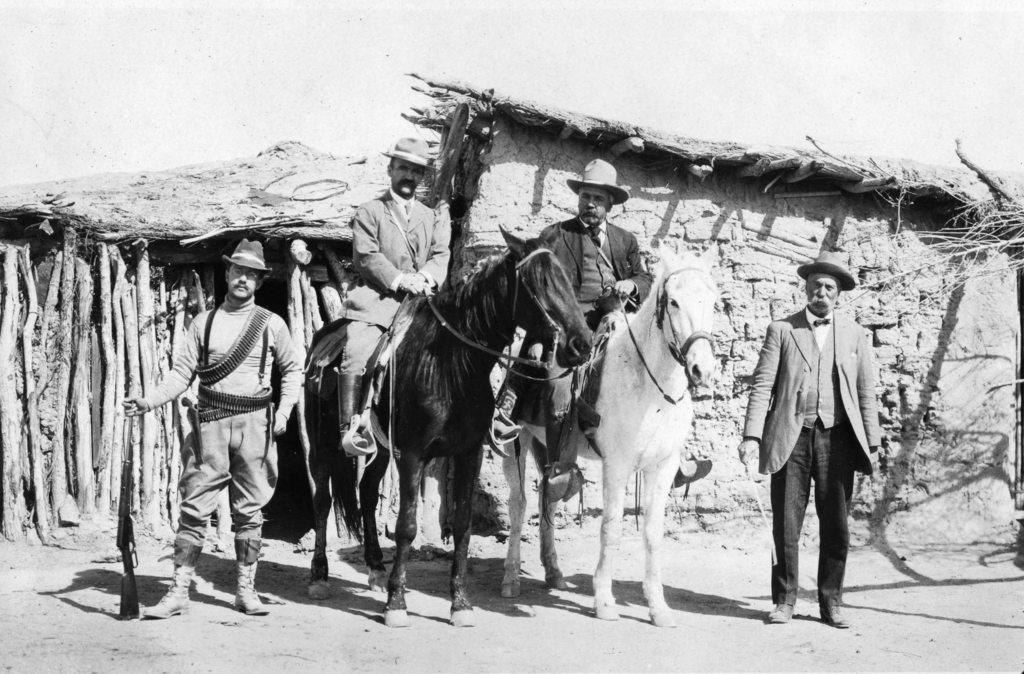Could you give a brief overview of what you see in this image? In the image we can see there are people who are standing and between there are two men who are sitting on horse and the image is in black and white colour. 